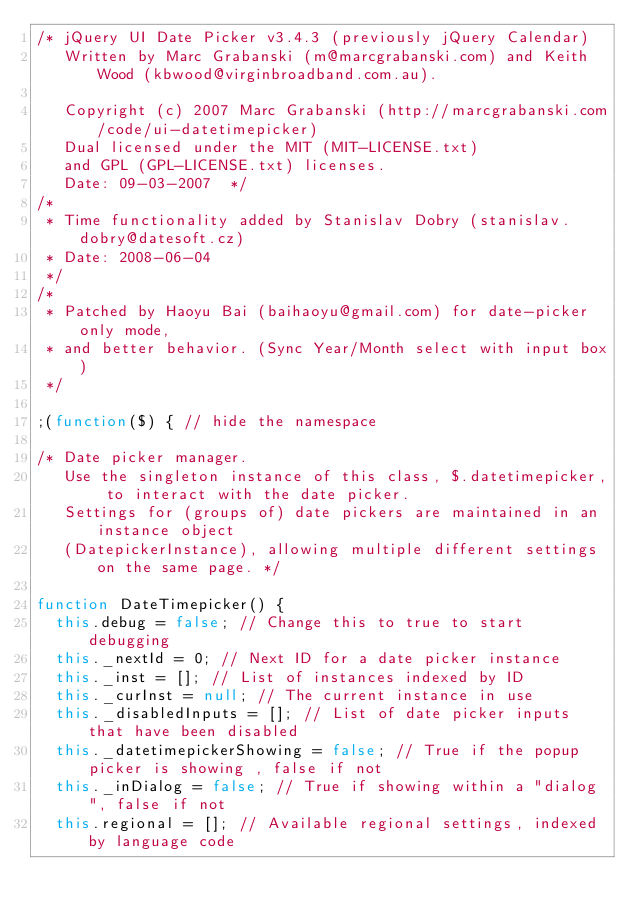Convert code to text. <code><loc_0><loc_0><loc_500><loc_500><_JavaScript_>/* jQuery UI Date Picker v3.4.3 (previously jQuery Calendar)
   Written by Marc Grabanski (m@marcgrabanski.com) and Keith Wood (kbwood@virginbroadband.com.au).

   Copyright (c) 2007 Marc Grabanski (http://marcgrabanski.com/code/ui-datetimepicker)
   Dual licensed under the MIT (MIT-LICENSE.txt)
   and GPL (GPL-LICENSE.txt) licenses.
   Date: 09-03-2007  */
/*
 * Time functionality added by Stanislav Dobry (stanislav.dobry@datesoft.cz)
 * Date: 2008-06-04
 */
/*
 * Patched by Haoyu Bai (baihaoyu@gmail.com) for date-picker only mode,
 * and better behavior. (Sync Year/Month select with input box)
 */

;(function($) { // hide the namespace

/* Date picker manager.
   Use the singleton instance of this class, $.datetimepicker, to interact with the date picker.
   Settings for (groups of) date pickers are maintained in an instance object
   (DatepickerInstance), allowing multiple different settings on the same page. */

function DateTimepicker() {
	this.debug = false; // Change this to true to start debugging
	this._nextId = 0; // Next ID for a date picker instance
	this._inst = []; // List of instances indexed by ID
	this._curInst = null; // The current instance in use
	this._disabledInputs = []; // List of date picker inputs that have been disabled
	this._datetimepickerShowing = false; // True if the popup picker is showing , false if not
	this._inDialog = false; // True if showing within a "dialog", false if not
	this.regional = []; // Available regional settings, indexed by language code</code> 